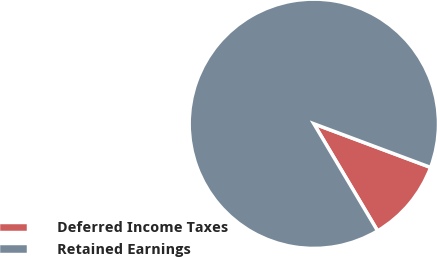Convert chart to OTSL. <chart><loc_0><loc_0><loc_500><loc_500><pie_chart><fcel>Deferred Income Taxes<fcel>Retained Earnings<nl><fcel>10.76%<fcel>89.24%<nl></chart> 